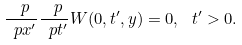Convert formula to latex. <formula><loc_0><loc_0><loc_500><loc_500>\frac { \ p } { \ p x ^ { \prime } } \frac { \ p } { \ p t ^ { \prime } } W ( 0 , t ^ { \prime } , y ) = 0 , \, \ t ^ { \prime } > 0 .</formula> 